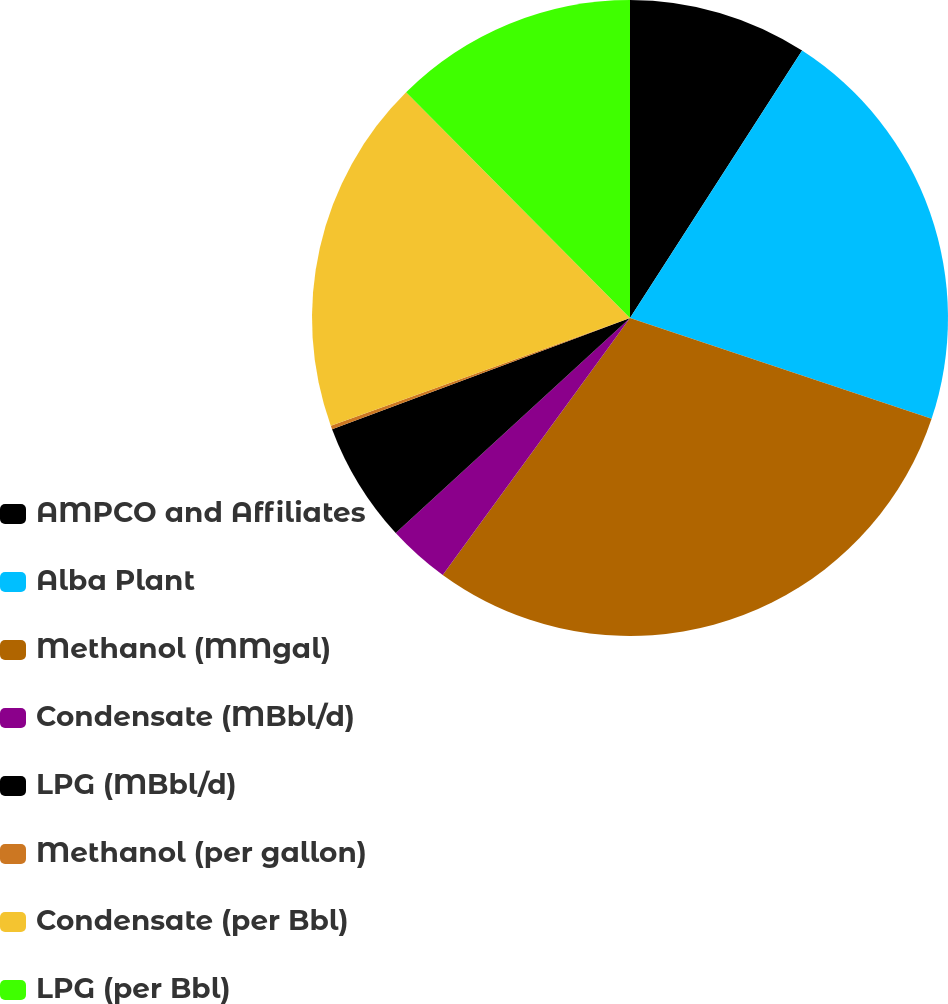Convert chart. <chart><loc_0><loc_0><loc_500><loc_500><pie_chart><fcel>AMPCO and Affiliates<fcel>Alba Plant<fcel>Methanol (MMgal)<fcel>Condensate (MBbl/d)<fcel>LPG (MBbl/d)<fcel>Methanol (per gallon)<fcel>Condensate (per Bbl)<fcel>LPG (per Bbl)<nl><fcel>9.1%<fcel>21.03%<fcel>29.88%<fcel>3.16%<fcel>6.13%<fcel>0.19%<fcel>18.06%<fcel>12.43%<nl></chart> 